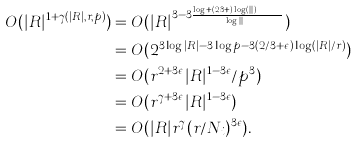<formula> <loc_0><loc_0><loc_500><loc_500>O ( | R | ^ { 1 + \gamma ( | R | , r , p ) } ) & = O ( | R | ^ { 3 - 3 \frac { \log p + ( 2 / 3 + \epsilon ) \log ( | R | / r ) } { \log | R | } } ) \\ & = O ( 2 ^ { 3 \log | R | - 3 \log p - 3 ( 2 / 3 + \epsilon ) \log ( | R | / r ) } ) \\ & = O ( r ^ { 2 + 3 \epsilon } | R | ^ { 1 - 3 \epsilon } / p ^ { 3 } ) \\ & = O ( r ^ { \gamma + 3 \epsilon } | R | ^ { 1 - 3 \epsilon } ) \\ & = O ( | R | r ^ { \gamma } ( r / N _ { i } ) ^ { 3 \epsilon } ) .</formula> 